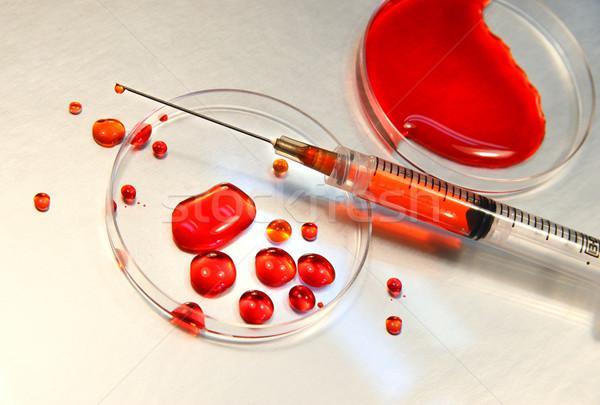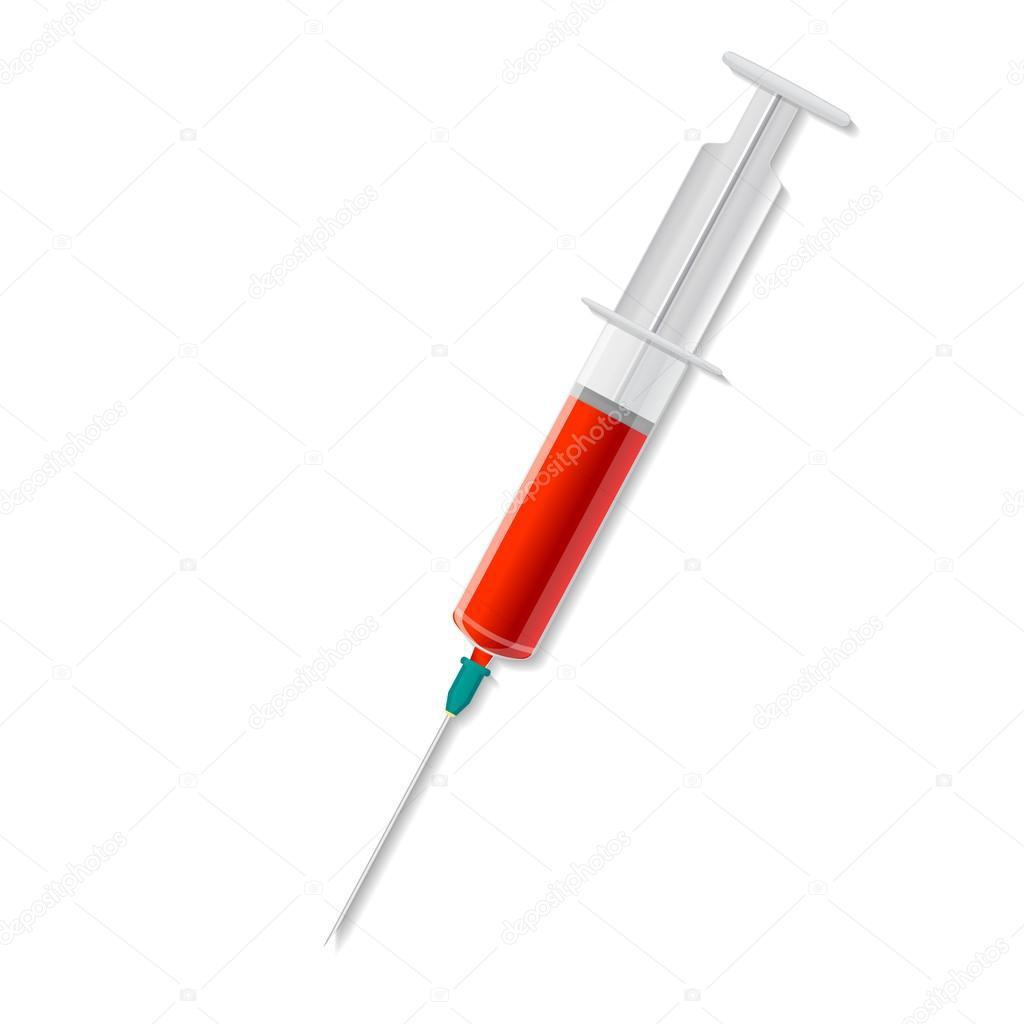The first image is the image on the left, the second image is the image on the right. Given the left and right images, does the statement "There are needles with red liquid and two hands." hold true? Answer yes or no. No. The first image is the image on the left, the second image is the image on the right. Given the left and right images, does the statement "A gloved hand holds an uncapped syringe in one image." hold true? Answer yes or no. No. 